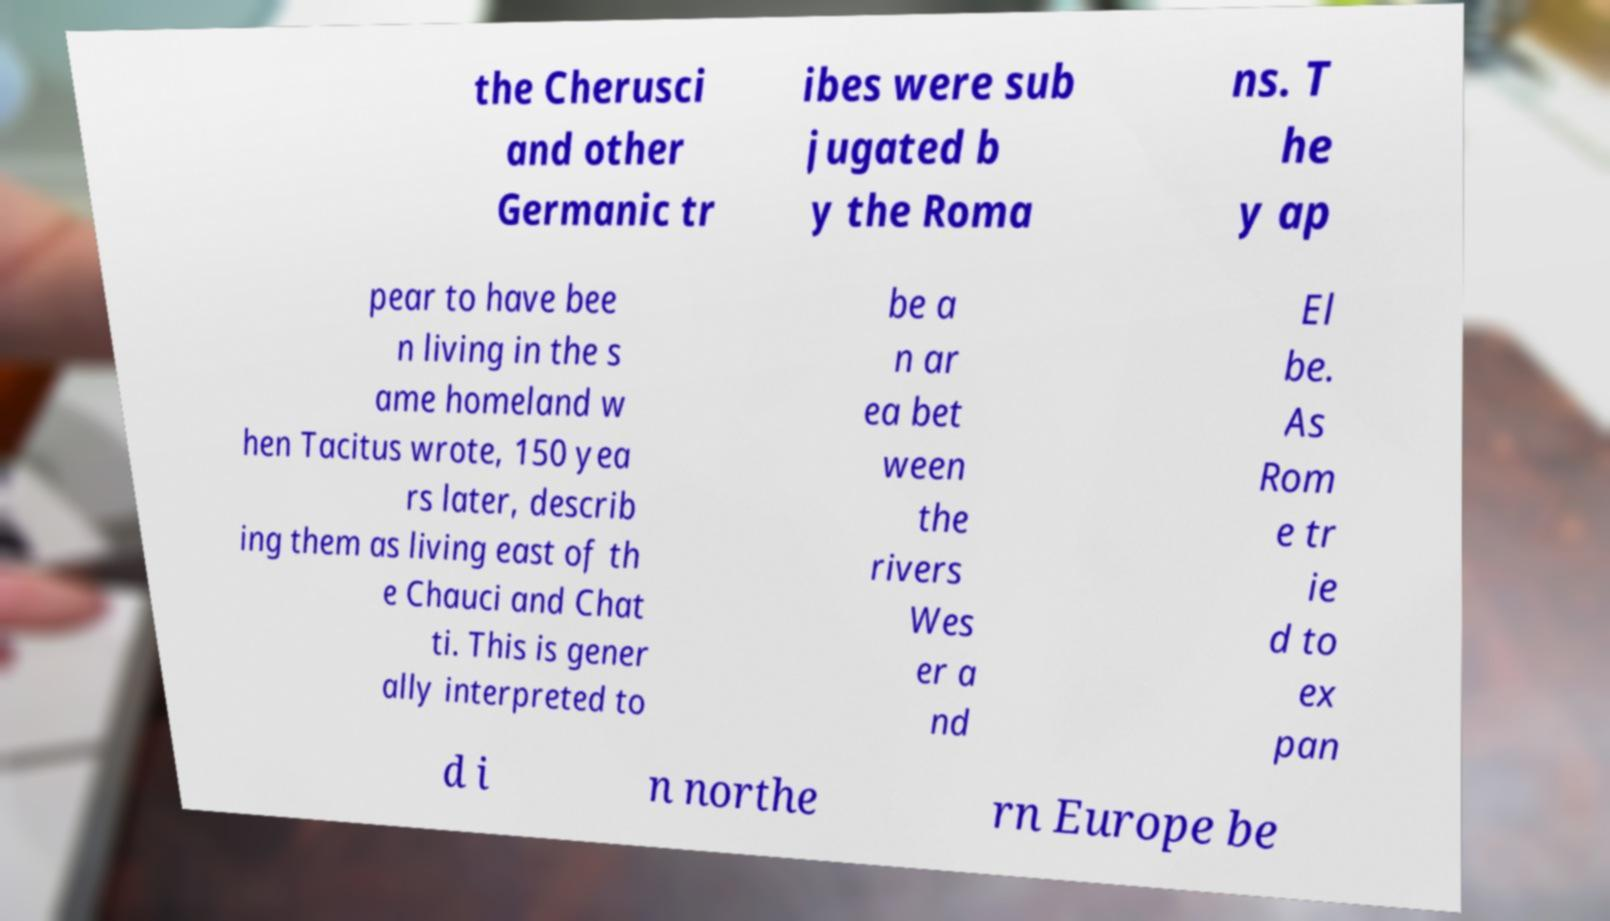Can you accurately transcribe the text from the provided image for me? the Cherusci and other Germanic tr ibes were sub jugated b y the Roma ns. T he y ap pear to have bee n living in the s ame homeland w hen Tacitus wrote, 150 yea rs later, describ ing them as living east of th e Chauci and Chat ti. This is gener ally interpreted to be a n ar ea bet ween the rivers Wes er a nd El be. As Rom e tr ie d to ex pan d i n northe rn Europe be 